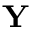<formula> <loc_0><loc_0><loc_500><loc_500>Y</formula> 